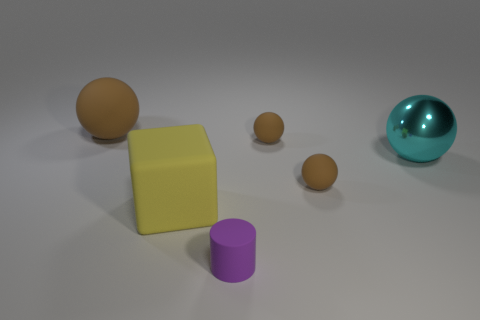Subtract all brown spheres. How many were subtracted if there are2brown spheres left? 1 Subtract all cyan metallic spheres. How many spheres are left? 3 Subtract 1 cylinders. How many cylinders are left? 0 Subtract all cyan balls. How many balls are left? 3 Add 1 small matte things. How many small matte things are left? 4 Add 3 tiny green cylinders. How many tiny green cylinders exist? 3 Add 2 tiny brown matte balls. How many objects exist? 8 Subtract 0 gray spheres. How many objects are left? 6 Subtract all blocks. How many objects are left? 5 Subtract all gray cylinders. Subtract all yellow balls. How many cylinders are left? 1 